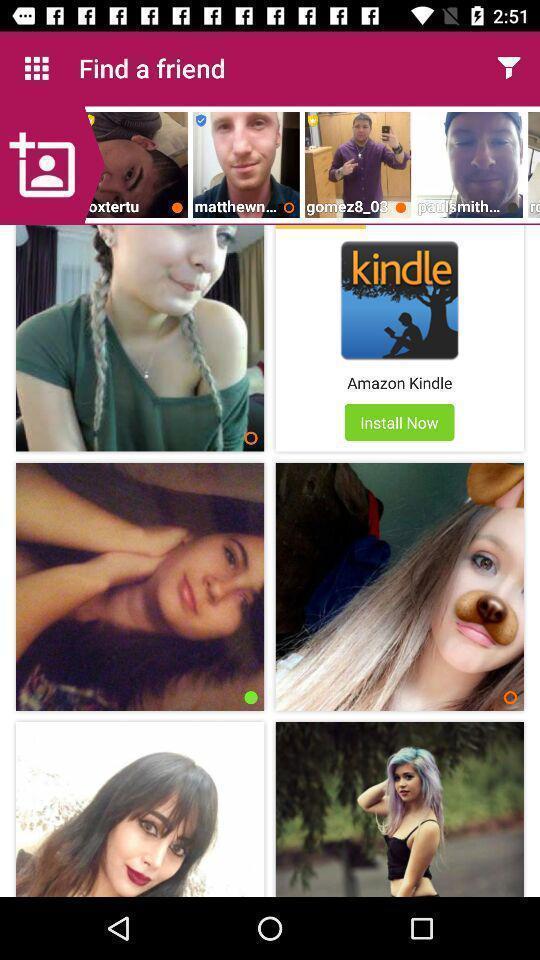Give me a summary of this screen capture. Screen showing various persons images in dating app. 